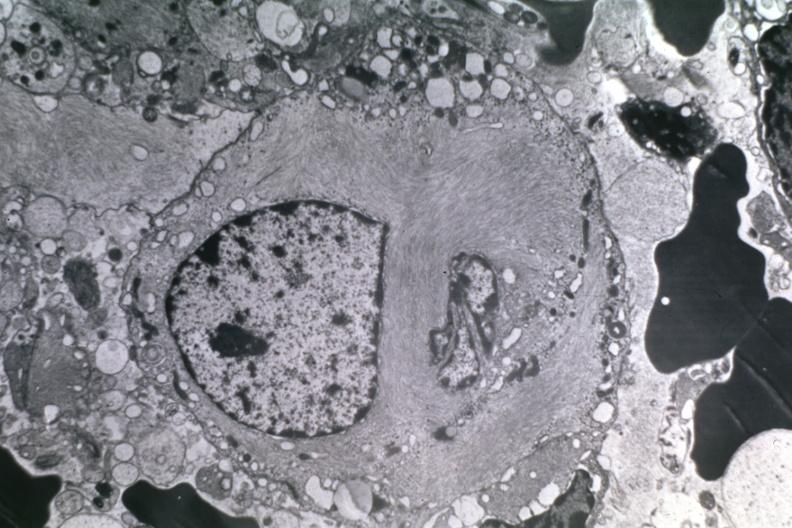what is present?
Answer the question using a single word or phrase. Anaplastic astrocytoma 